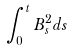Convert formula to latex. <formula><loc_0><loc_0><loc_500><loc_500>\int _ { 0 } ^ { t } B _ { s } ^ { 2 } d s</formula> 